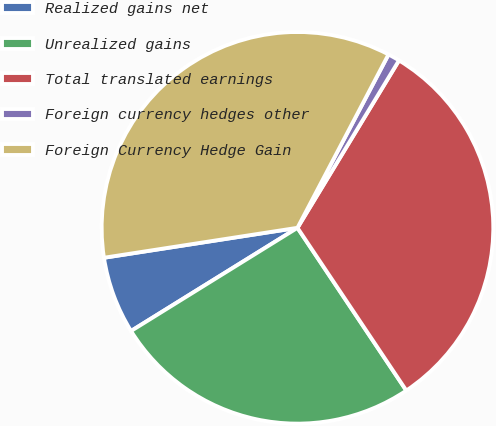<chart> <loc_0><loc_0><loc_500><loc_500><pie_chart><fcel>Realized gains net<fcel>Unrealized gains<fcel>Total translated earnings<fcel>Foreign currency hedges other<fcel>Foreign Currency Hedge Gain<nl><fcel>6.39%<fcel>25.55%<fcel>31.94%<fcel>0.98%<fcel>35.14%<nl></chart> 